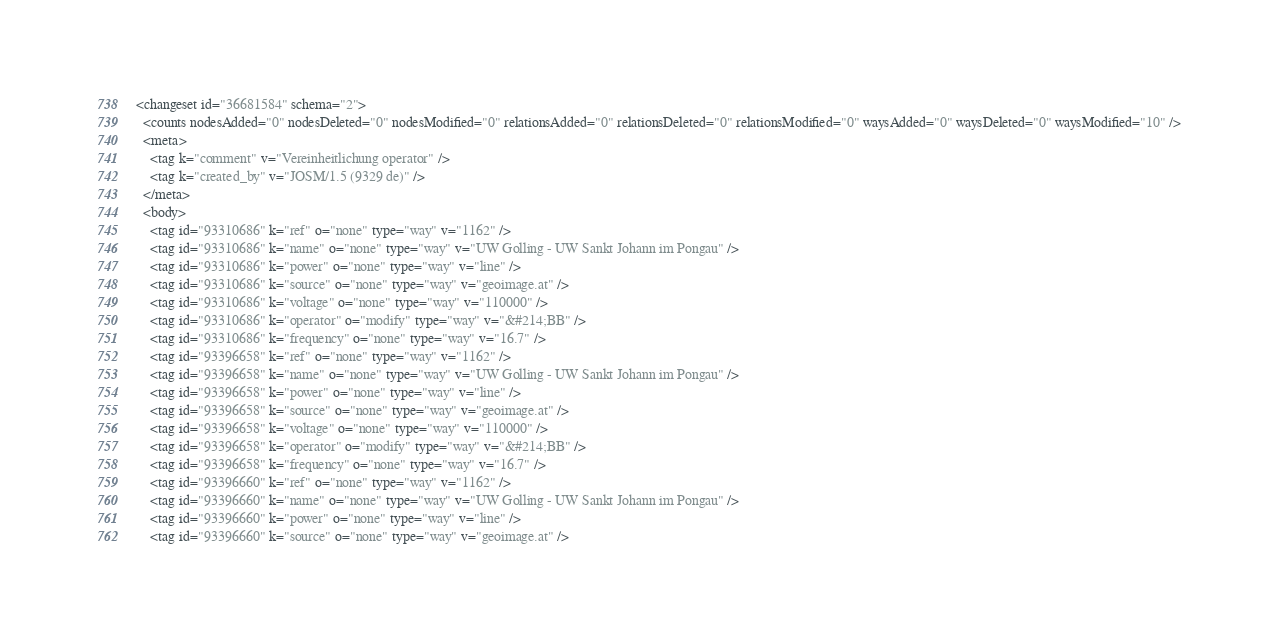<code> <loc_0><loc_0><loc_500><loc_500><_XML_><changeset id="36681584" schema="2">
  <counts nodesAdded="0" nodesDeleted="0" nodesModified="0" relationsAdded="0" relationsDeleted="0" relationsModified="0" waysAdded="0" waysDeleted="0" waysModified="10" />
  <meta>
    <tag k="comment" v="Vereinheitlichung operator" />
    <tag k="created_by" v="JOSM/1.5 (9329 de)" />
  </meta>
  <body>
    <tag id="93310686" k="ref" o="none" type="way" v="1162" />
    <tag id="93310686" k="name" o="none" type="way" v="UW Golling - UW Sankt Johann im Pongau" />
    <tag id="93310686" k="power" o="none" type="way" v="line" />
    <tag id="93310686" k="source" o="none" type="way" v="geoimage.at" />
    <tag id="93310686" k="voltage" o="none" type="way" v="110000" />
    <tag id="93310686" k="operator" o="modify" type="way" v="&#214;BB" />
    <tag id="93310686" k="frequency" o="none" type="way" v="16.7" />
    <tag id="93396658" k="ref" o="none" type="way" v="1162" />
    <tag id="93396658" k="name" o="none" type="way" v="UW Golling - UW Sankt Johann im Pongau" />
    <tag id="93396658" k="power" o="none" type="way" v="line" />
    <tag id="93396658" k="source" o="none" type="way" v="geoimage.at" />
    <tag id="93396658" k="voltage" o="none" type="way" v="110000" />
    <tag id="93396658" k="operator" o="modify" type="way" v="&#214;BB" />
    <tag id="93396658" k="frequency" o="none" type="way" v="16.7" />
    <tag id="93396660" k="ref" o="none" type="way" v="1162" />
    <tag id="93396660" k="name" o="none" type="way" v="UW Golling - UW Sankt Johann im Pongau" />
    <tag id="93396660" k="power" o="none" type="way" v="line" />
    <tag id="93396660" k="source" o="none" type="way" v="geoimage.at" /></code> 